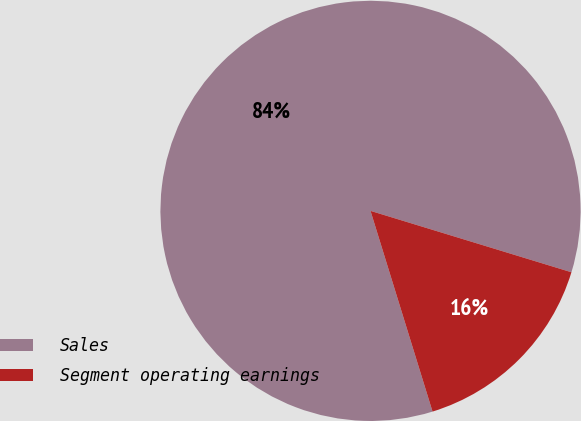Convert chart to OTSL. <chart><loc_0><loc_0><loc_500><loc_500><pie_chart><fcel>Sales<fcel>Segment operating earnings<nl><fcel>84.49%<fcel>15.51%<nl></chart> 